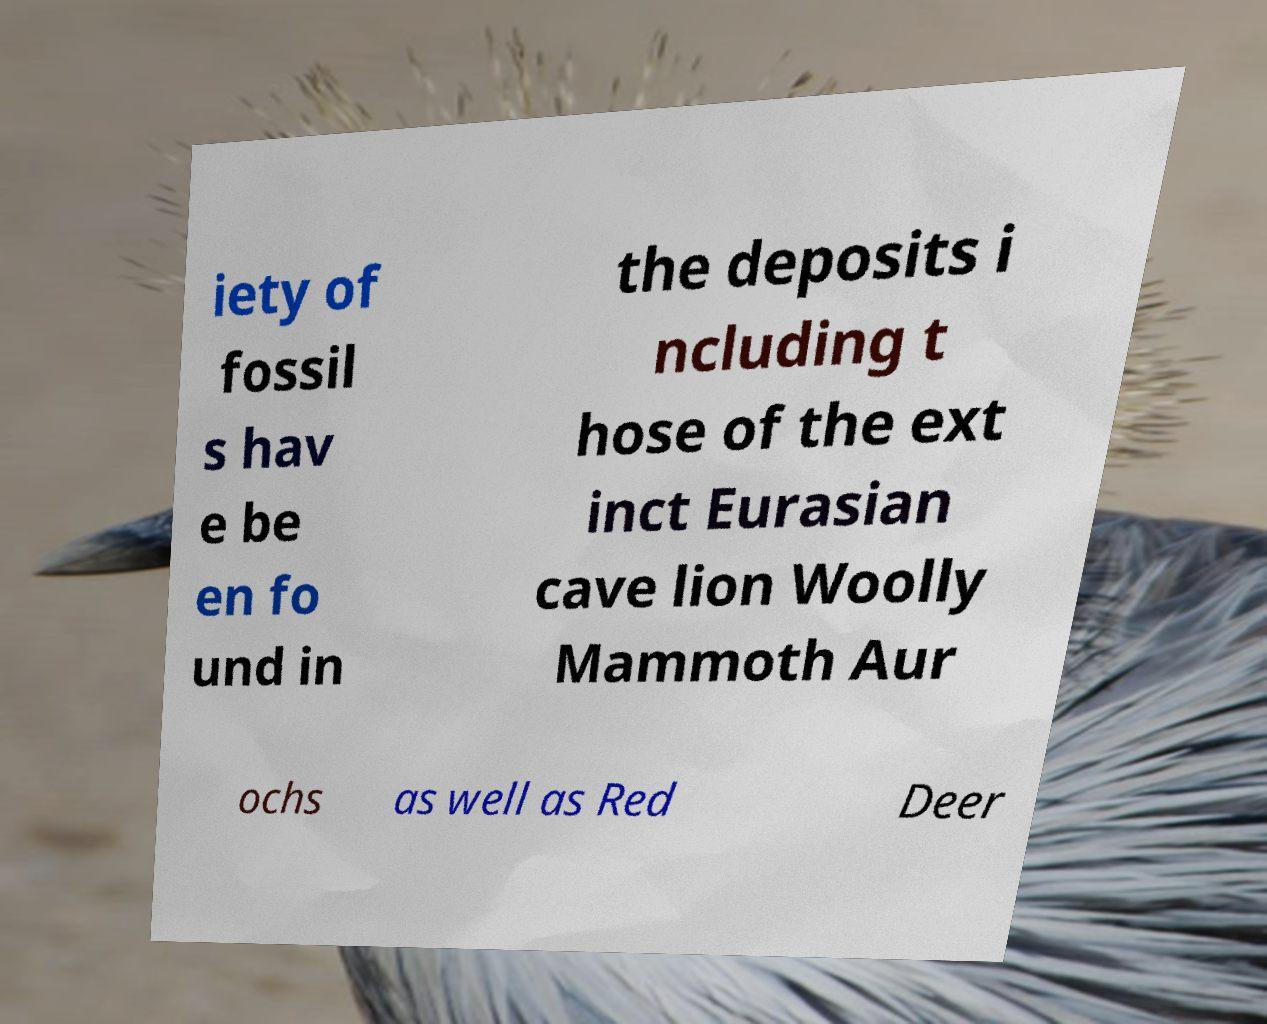What messages or text are displayed in this image? I need them in a readable, typed format. iety of fossil s hav e be en fo und in the deposits i ncluding t hose of the ext inct Eurasian cave lion Woolly Mammoth Aur ochs as well as Red Deer 